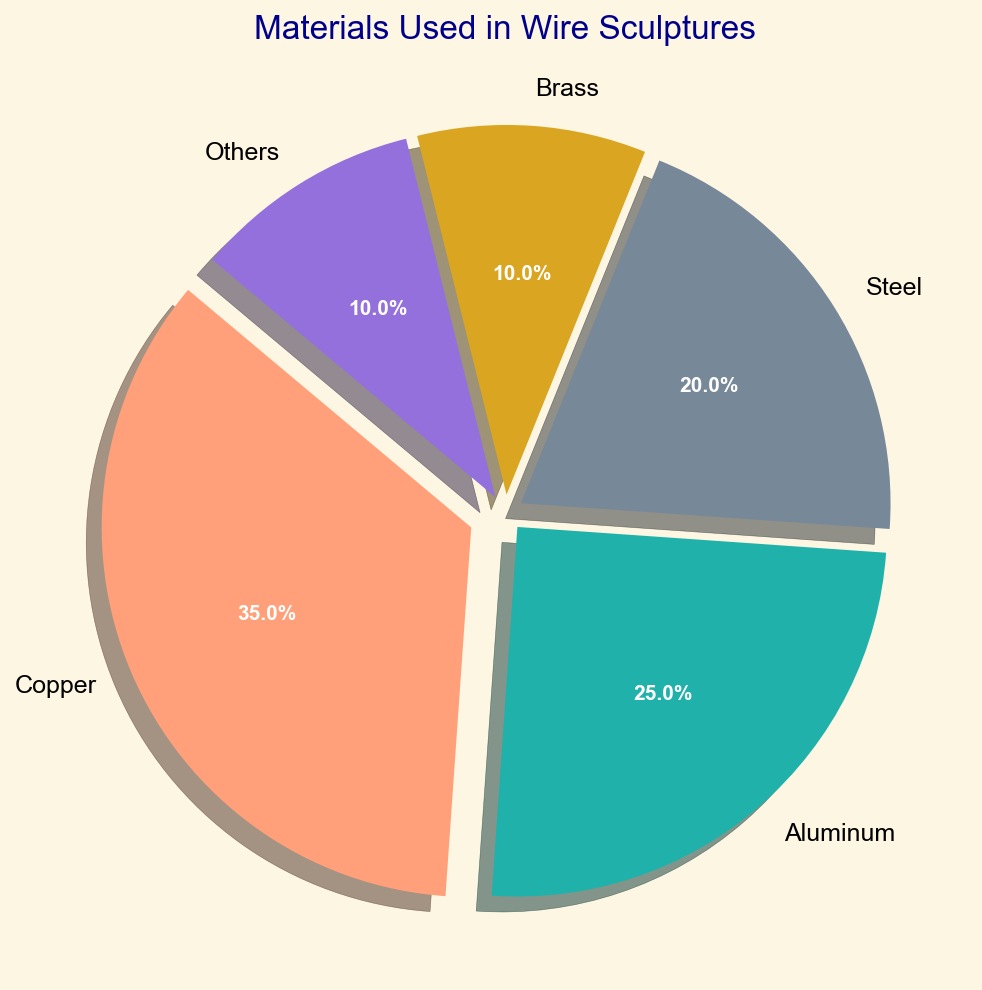What is the most frequently used material in the wire sculptures? The figure shows that the material with the highest percentage slice is Copper, which is separated from the other slices for emphasis.
Answer: Copper Which material is used the least in the wire sculptures? According to the pie chart, Brass and Others both have the smallest slices, each representing 10% of the materials used.
Answer: Brass and Others By how much does the usage of Copper exceed that of Aluminum? Copper is used 35% of the time, and Aluminum is used 25% of the time. The difference between their usage is 35% - 25%.
Answer: 10% What is the combined percentage usage of Steel and Brass in the sculptures? The chart indicates that Steel is 20% and Brass is 10%. Adding these percentages together, 20% + 10% gives us the total combined usage.
Answer: 30% Which material has a larger percentage: Steel or Aluminum, and by how much? The pie chart shows that Steel is 20% and Aluminum is 25%. Aluminum has a larger percentage, and the difference is 25% - 20%.
Answer: Aluminum, by 5% What color represents the material with the smallest usage in the sculptures? The pie chart utilizes distinct colors for each material. Brass and Others have the smallest usage (10%). Reviewing their specific colors should give us the required answer.
Answer: Brass: Gold, Others: Purple What percentage of the materials are non-metallic ("Others")? The chart includes a slice labeled "Others," which accounts for 10% of the materials used.
Answer: 10% Which two materials have combined usage approximately equal to the usage of Copper? Copper usage is 35%. Combining other slices: Aluminum (25%) + Brass (10%) gives 25% + 10%, which is 35%, equal to Copper's usage.
Answer: Aluminum and Brass Is the percentage usage of Steel closer to that of Brass or Aluminum? Comparing the percentages, Steel is 20%, Brass is 10%, and Aluminum is 25%. The difference between Steel and Brass is 10%, and the difference between Steel and Aluminum is 5%. Therefore, Steel is closer to Aluminum.
Answer: Aluminum 